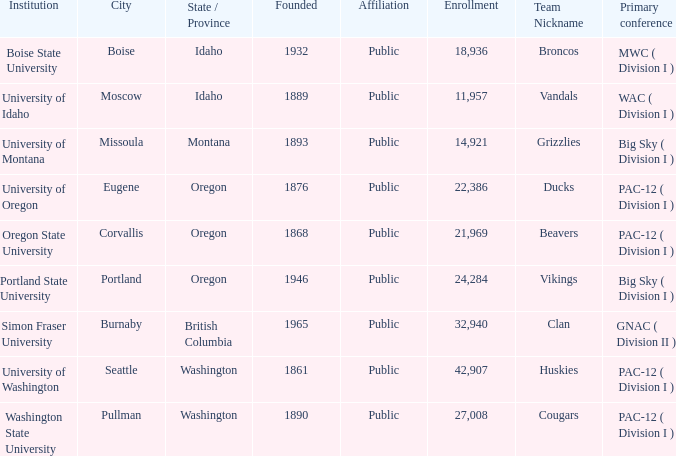What is the location of the team nicknamed Broncos, which was founded after 1889? Boise, Idaho. 